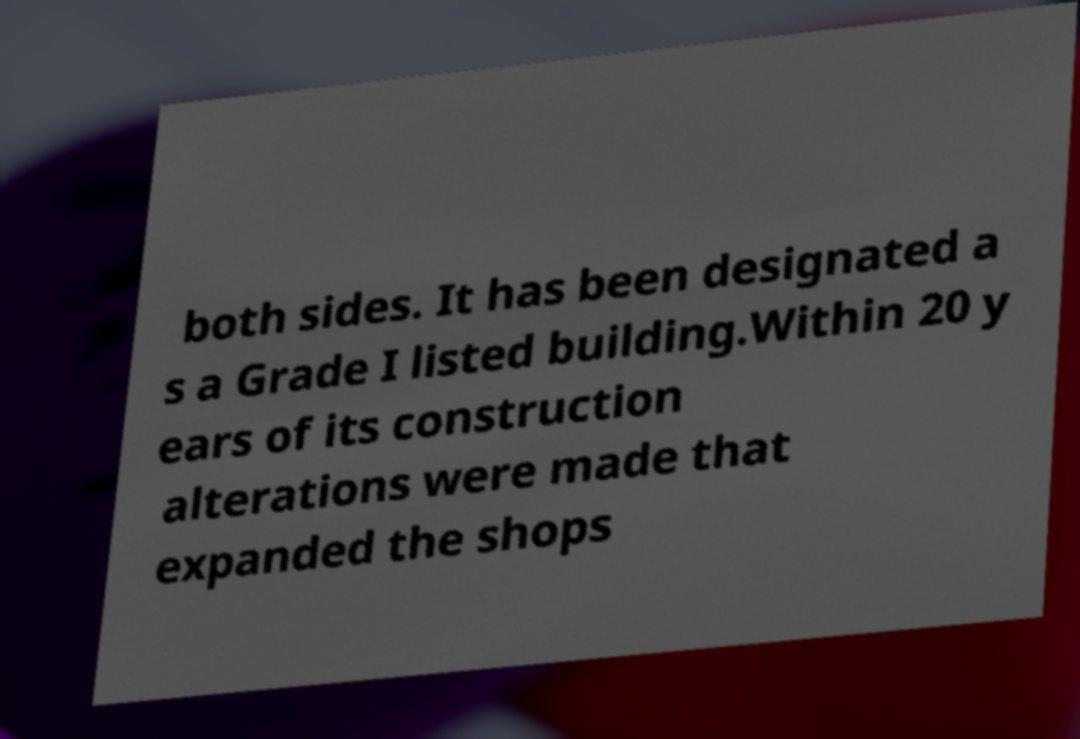Can you accurately transcribe the text from the provided image for me? both sides. It has been designated a s a Grade I listed building.Within 20 y ears of its construction alterations were made that expanded the shops 